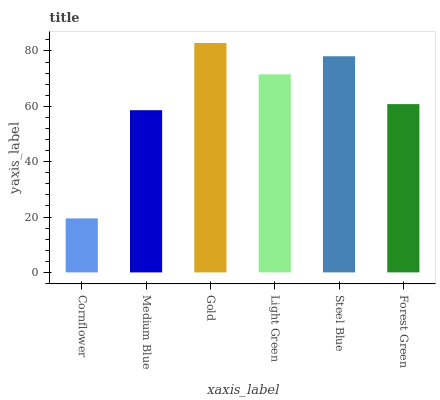Is Cornflower the minimum?
Answer yes or no. Yes. Is Gold the maximum?
Answer yes or no. Yes. Is Medium Blue the minimum?
Answer yes or no. No. Is Medium Blue the maximum?
Answer yes or no. No. Is Medium Blue greater than Cornflower?
Answer yes or no. Yes. Is Cornflower less than Medium Blue?
Answer yes or no. Yes. Is Cornflower greater than Medium Blue?
Answer yes or no. No. Is Medium Blue less than Cornflower?
Answer yes or no. No. Is Light Green the high median?
Answer yes or no. Yes. Is Forest Green the low median?
Answer yes or no. Yes. Is Medium Blue the high median?
Answer yes or no. No. Is Medium Blue the low median?
Answer yes or no. No. 